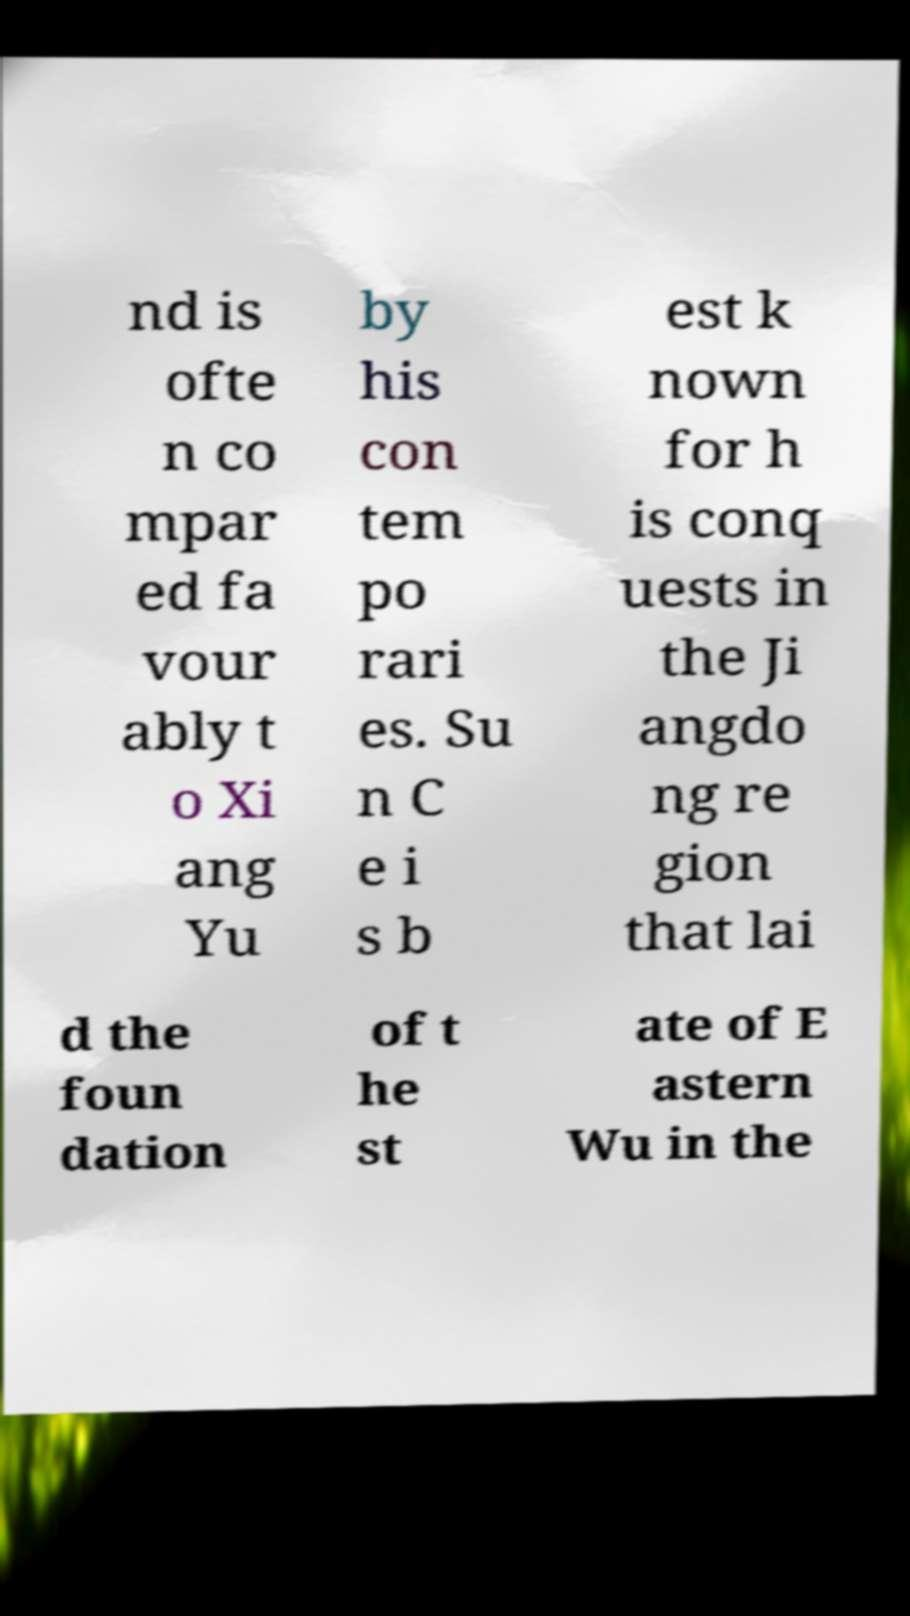What messages or text are displayed in this image? I need them in a readable, typed format. nd is ofte n co mpar ed fa vour ably t o Xi ang Yu by his con tem po rari es. Su n C e i s b est k nown for h is conq uests in the Ji angdo ng re gion that lai d the foun dation of t he st ate of E astern Wu in the 